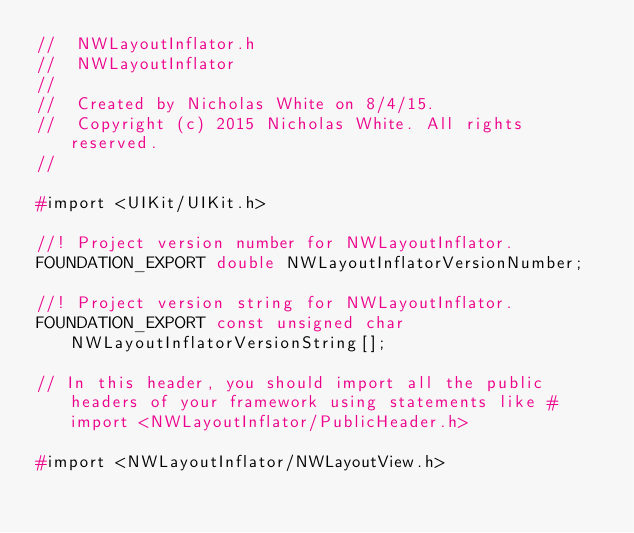<code> <loc_0><loc_0><loc_500><loc_500><_C_>//  NWLayoutInflator.h
//  NWLayoutInflator
//
//  Created by Nicholas White on 8/4/15.
//  Copyright (c) 2015 Nicholas White. All rights reserved.
//

#import <UIKit/UIKit.h>

//! Project version number for NWLayoutInflator.
FOUNDATION_EXPORT double NWLayoutInflatorVersionNumber;

//! Project version string for NWLayoutInflator.
FOUNDATION_EXPORT const unsigned char NWLayoutInflatorVersionString[];

// In this header, you should import all the public headers of your framework using statements like #import <NWLayoutInflator/PublicHeader.h>

#import <NWLayoutInflator/NWLayoutView.h>
</code> 